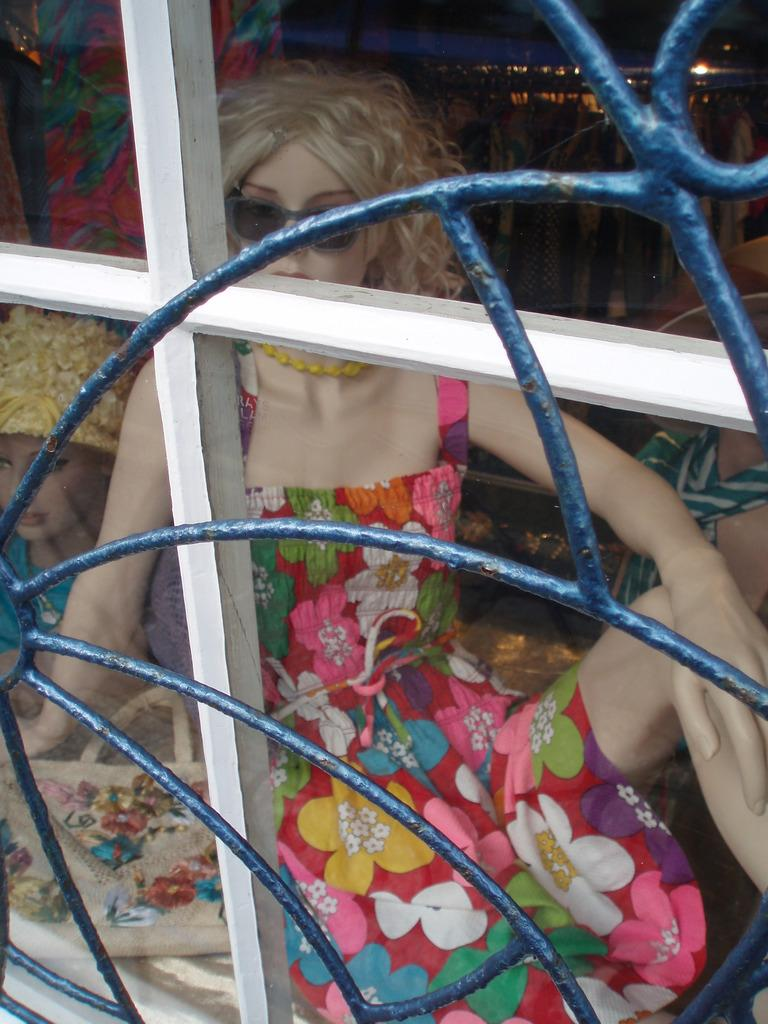What type of material is used for the railing in the image? The railing in the image is made of metal. What is the transparent material in the image? There is glass in the image. What can be seen through the glass? Mannequins with dresses are visible through the glass. What is the color of the background in the image? The background of the image is black. Can you hear the cup crying in the image? There is no cup or any indication of crying in the image. 